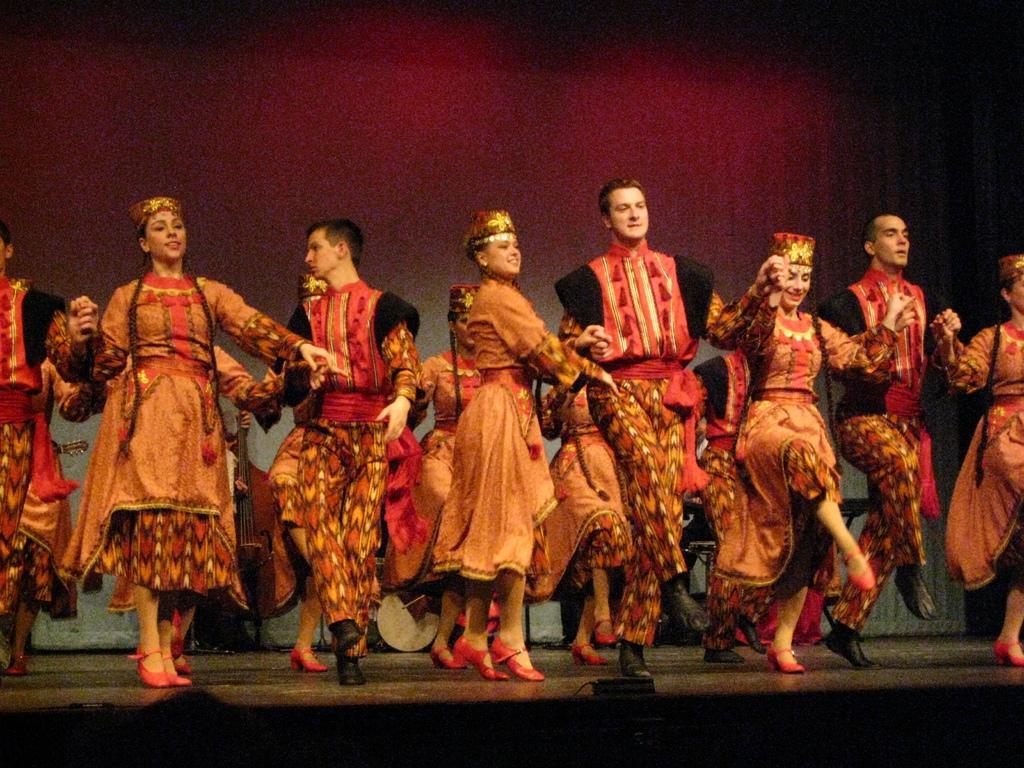How would you summarize this image in a sentence or two? In this image, we can see a group of people are dancing on the stage. Here we can see some black color object. Few people are smiling. Background we can see a curtain and some musical instruments. 